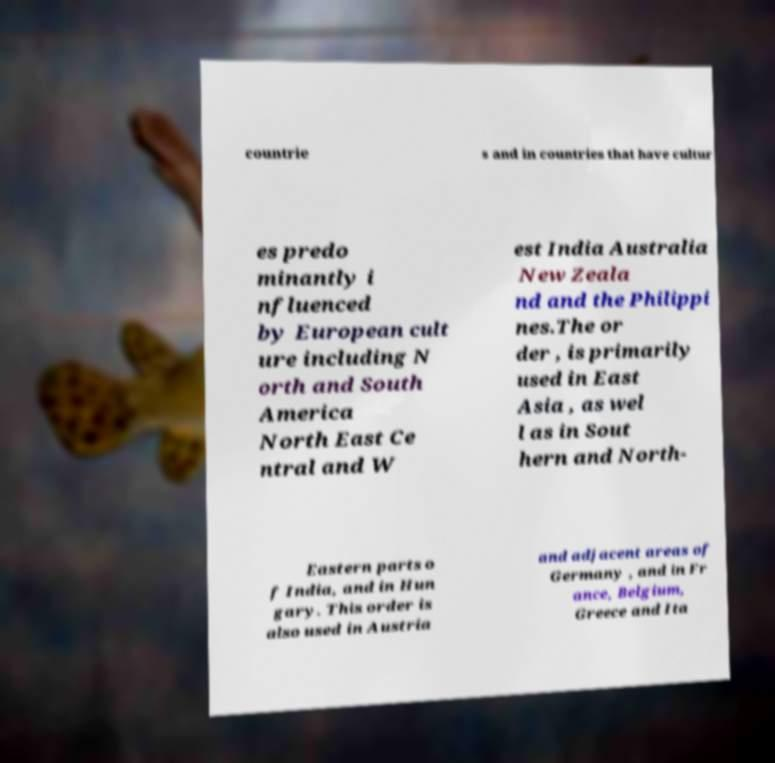I need the written content from this picture converted into text. Can you do that? countrie s and in countries that have cultur es predo minantly i nfluenced by European cult ure including N orth and South America North East Ce ntral and W est India Australia New Zeala nd and the Philippi nes.The or der , is primarily used in East Asia , as wel l as in Sout hern and North- Eastern parts o f India, and in Hun gary. This order is also used in Austria and adjacent areas of Germany , and in Fr ance, Belgium, Greece and Ita 